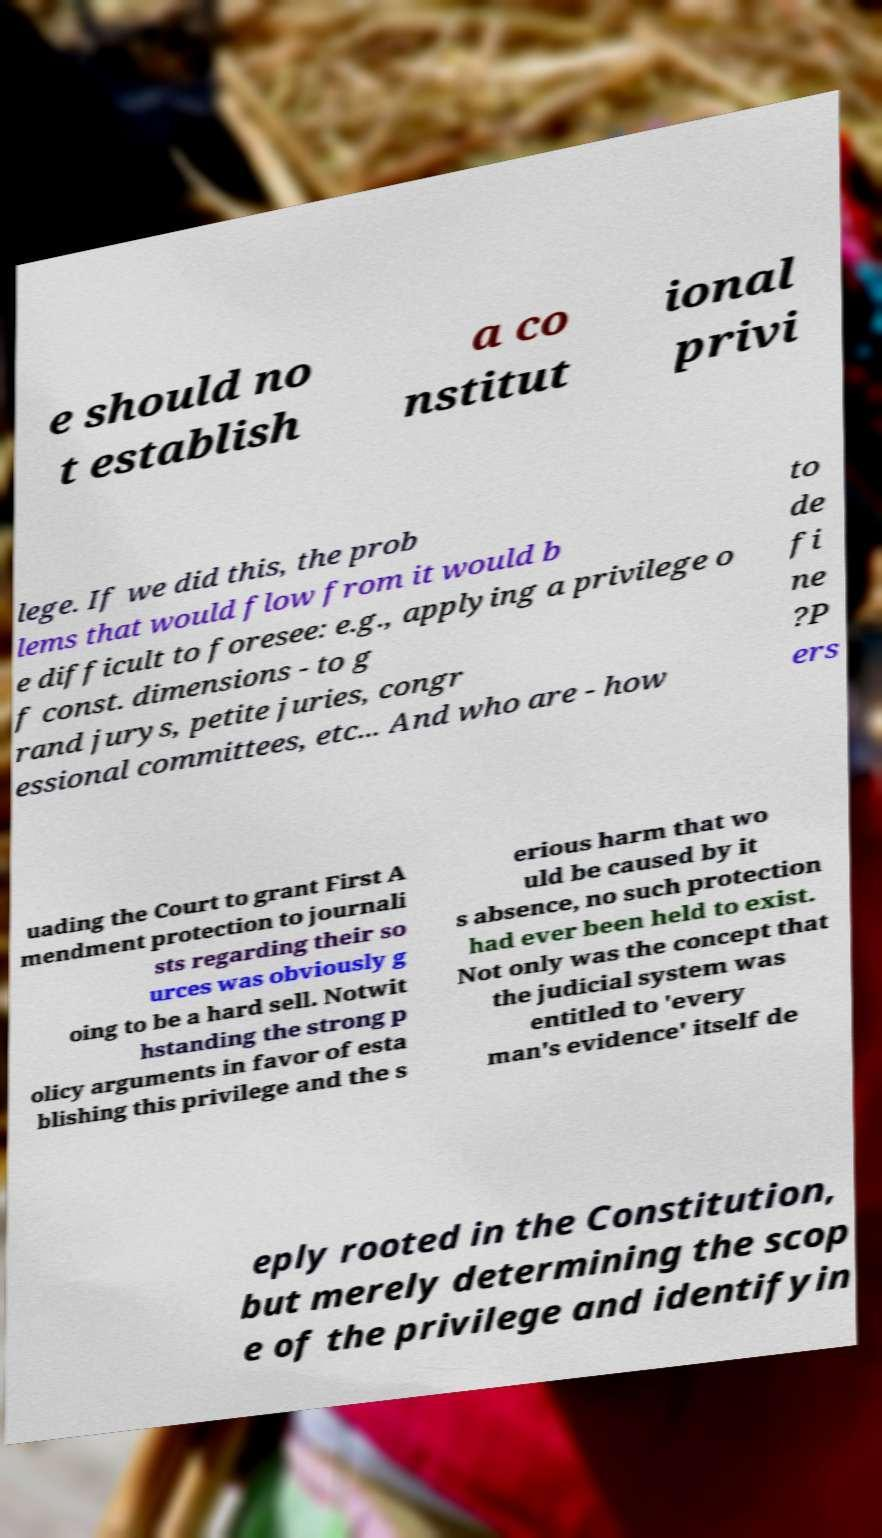Could you extract and type out the text from this image? e should no t establish a co nstitut ional privi lege. If we did this, the prob lems that would flow from it would b e difficult to foresee: e.g., applying a privilege o f const. dimensions - to g rand jurys, petite juries, congr essional committees, etc... And who are - how to de fi ne ?P ers uading the Court to grant First A mendment protection to journali sts regarding their so urces was obviously g oing to be a hard sell. Notwit hstanding the strong p olicy arguments in favor of esta blishing this privilege and the s erious harm that wo uld be caused by it s absence, no such protection had ever been held to exist. Not only was the concept that the judicial system was entitled to 'every man's evidence' itself de eply rooted in the Constitution, but merely determining the scop e of the privilege and identifyin 